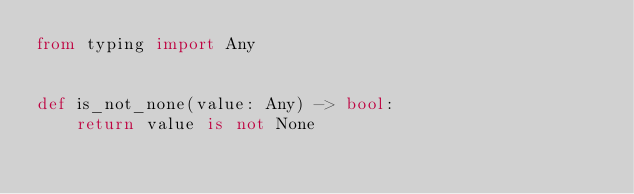Convert code to text. <code><loc_0><loc_0><loc_500><loc_500><_Python_>from typing import Any


def is_not_none(value: Any) -> bool:
    return value is not None
</code> 